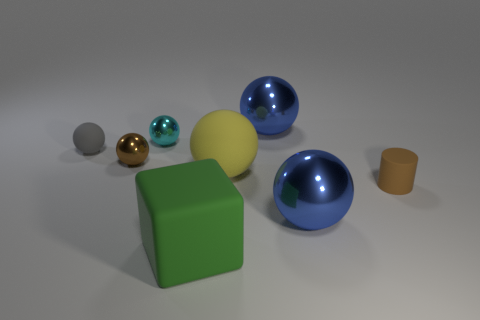Subtract all big metallic spheres. How many spheres are left? 4 Subtract 3 balls. How many balls are left? 3 Subtract all blue balls. How many balls are left? 4 Subtract all yellow balls. Subtract all gray cylinders. How many balls are left? 5 Add 1 brown cylinders. How many objects exist? 9 Subtract all cylinders. How many objects are left? 7 Subtract all large green rubber blocks. Subtract all small metal spheres. How many objects are left? 5 Add 6 large blue spheres. How many large blue spheres are left? 8 Add 5 big yellow balls. How many big yellow balls exist? 6 Subtract 0 cyan cylinders. How many objects are left? 8 